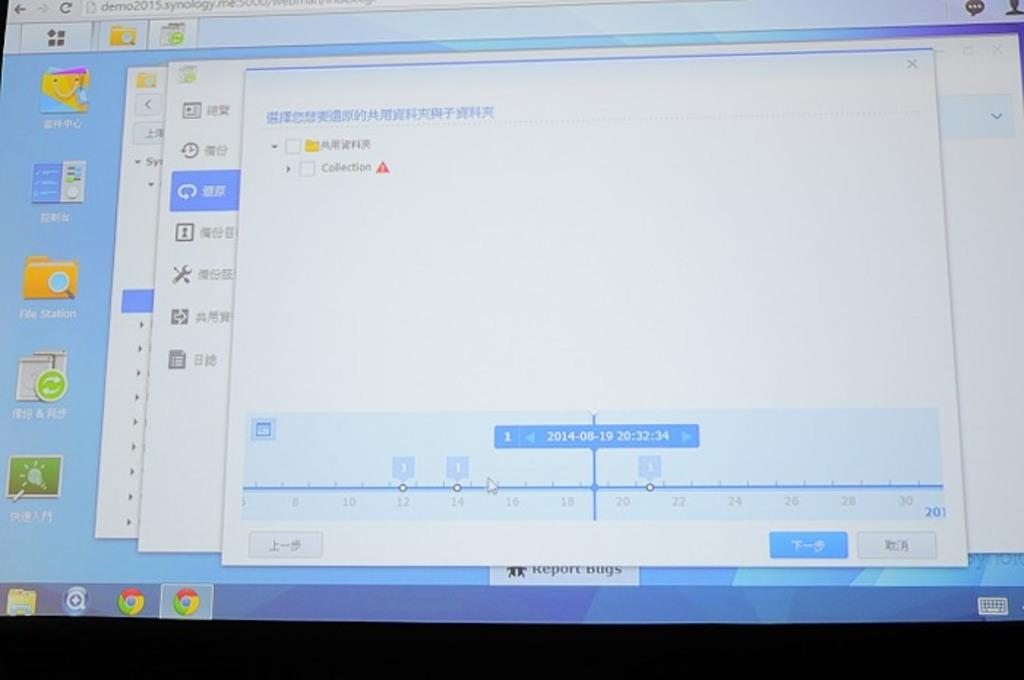What is the main subject in the center of the image? There is a screen in the center of the image. What type of work can be seen being done on the screen in the image? There is no work being done on the screen in the image, as it is not mentioned in the provided facts. 